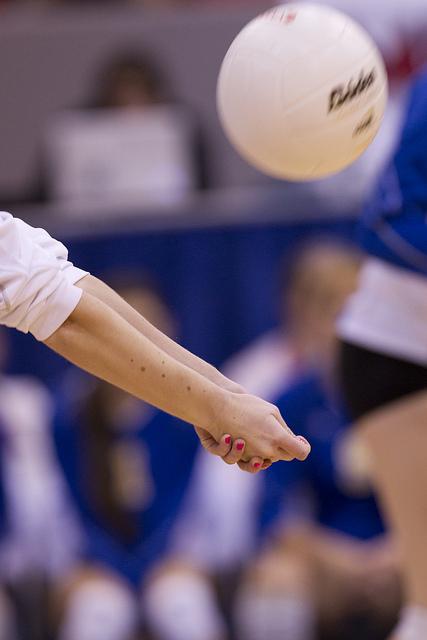Are there people sitting in the background?
Be succinct. Yes. What hand is the person holding on the top?
Concise answer only. Right. What sport is this?
Give a very brief answer. Volleyball. 